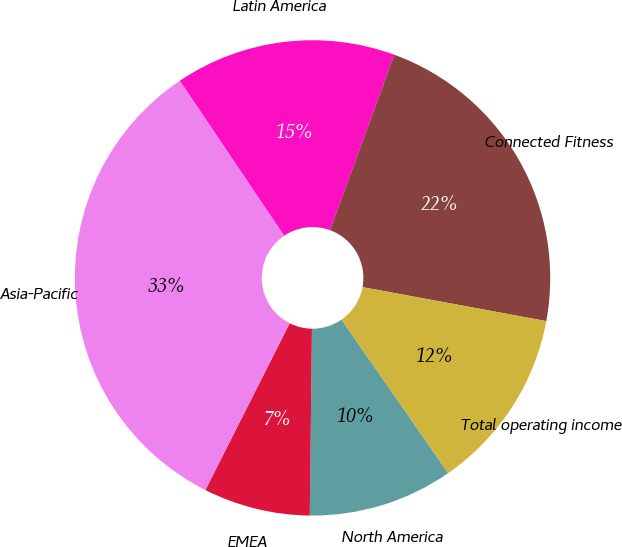Convert chart. <chart><loc_0><loc_0><loc_500><loc_500><pie_chart><fcel>North America<fcel>EMEA<fcel>Asia-Pacific<fcel>Latin America<fcel>Connected Fitness<fcel>Total operating income<nl><fcel>9.85%<fcel>7.26%<fcel>33.13%<fcel>15.02%<fcel>22.32%<fcel>12.43%<nl></chart> 